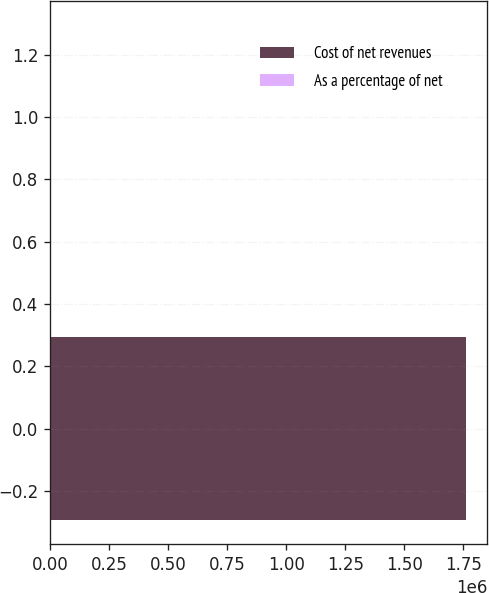<chart> <loc_0><loc_0><loc_500><loc_500><bar_chart><fcel>Cost of net revenues<fcel>As a percentage of net<nl><fcel>1.76297e+06<fcel>23<nl></chart> 